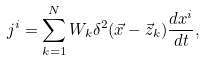<formula> <loc_0><loc_0><loc_500><loc_500>j ^ { i } = \sum _ { k = 1 } ^ { N } W _ { k } \delta ^ { 2 } ( \vec { x } - \vec { z } _ { k } ) \frac { d x ^ { i } } { d t } ,</formula> 